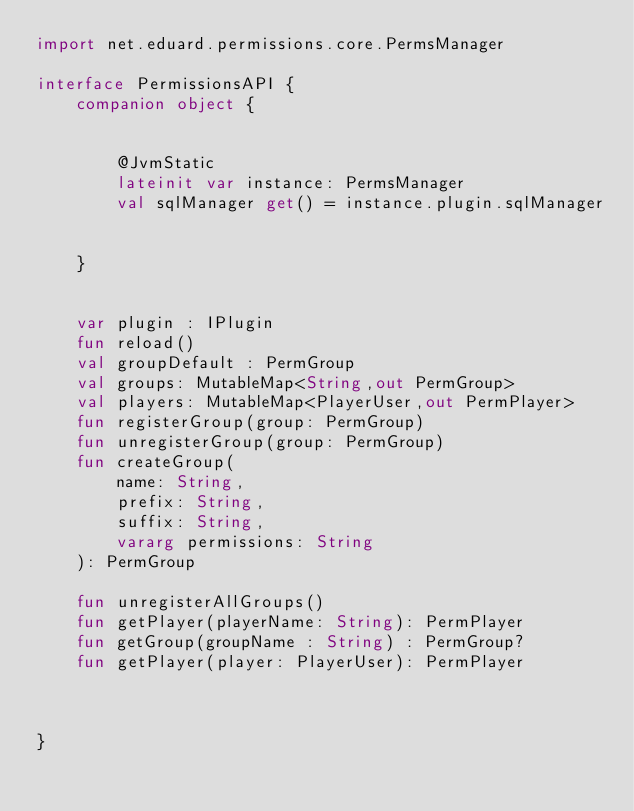Convert code to text. <code><loc_0><loc_0><loc_500><loc_500><_Kotlin_>import net.eduard.permissions.core.PermsManager

interface PermissionsAPI {
    companion object {


        @JvmStatic
        lateinit var instance: PermsManager
        val sqlManager get() = instance.plugin.sqlManager


    }


    var plugin : IPlugin
    fun reload()
    val groupDefault : PermGroup
    val groups: MutableMap<String,out PermGroup>
    val players: MutableMap<PlayerUser,out PermPlayer>
    fun registerGroup(group: PermGroup)
    fun unregisterGroup(group: PermGroup)
    fun createGroup(
        name: String,
        prefix: String,
        suffix: String,
        vararg permissions: String
    ): PermGroup

    fun unregisterAllGroups()
    fun getPlayer(playerName: String): PermPlayer
    fun getGroup(groupName : String) : PermGroup?
    fun getPlayer(player: PlayerUser): PermPlayer



}</code> 